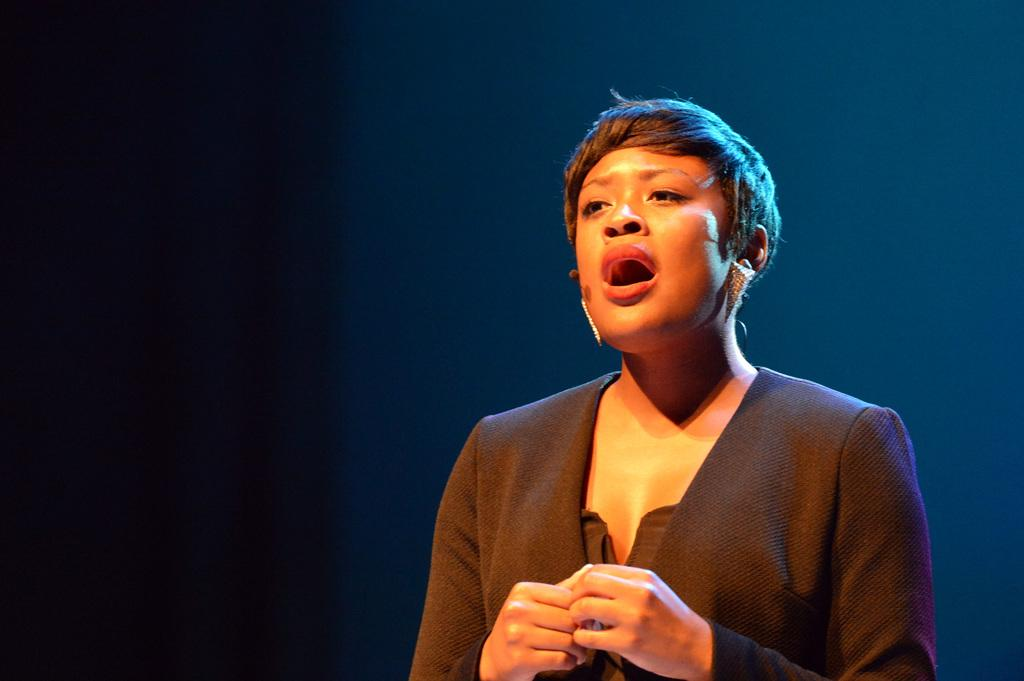What is the main subject of the image? There is a person standing in the image. Where is the person located in the image? The person is on the right side of the image. What is the person wearing in the image? The person is wearing a black color blazer. Can you see any cheese in the image? There is no cheese present in the image. Is the moon visible in the image? The moon is not visible in the image. 